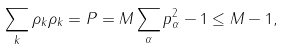Convert formula to latex. <formula><loc_0><loc_0><loc_500><loc_500>\sum _ { k } \rho _ { k } \rho _ { k } = P = M \sum _ { \alpha } p ^ { 2 } _ { \alpha } - 1 \leq M - 1 ,</formula> 